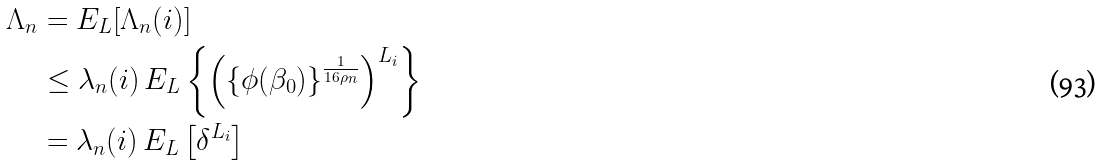<formula> <loc_0><loc_0><loc_500><loc_500>\Lambda _ { n } & = { E } _ { L } [ \Lambda _ { n } ( i ) ] \\ & \leq \lambda _ { n } ( i ) \, { E } _ { L } \left \{ \left ( \left \{ \phi ( \beta _ { 0 } ) \right \} ^ { \frac { 1 } { 1 6 \rho _ { n } } } \right ) ^ { L _ { i } } \right \} \\ & = \lambda _ { n } ( i ) \, { E } _ { L } \left [ \delta ^ { L _ { i } } \right ]</formula> 